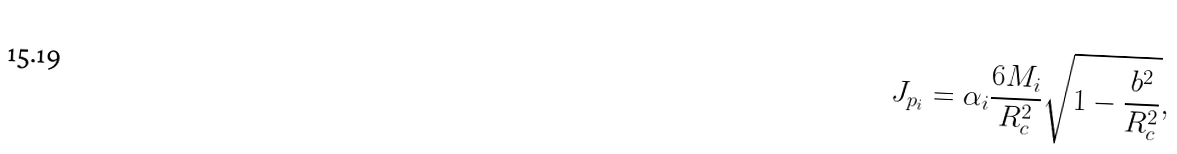Convert formula to latex. <formula><loc_0><loc_0><loc_500><loc_500>J _ { p _ { i } } = \alpha _ { i } \frac { 6 M _ { i } } { R _ { c } ^ { 2 } } \sqrt { 1 - \frac { b ^ { 2 } } { R _ { c } ^ { 2 } } } ,</formula> 